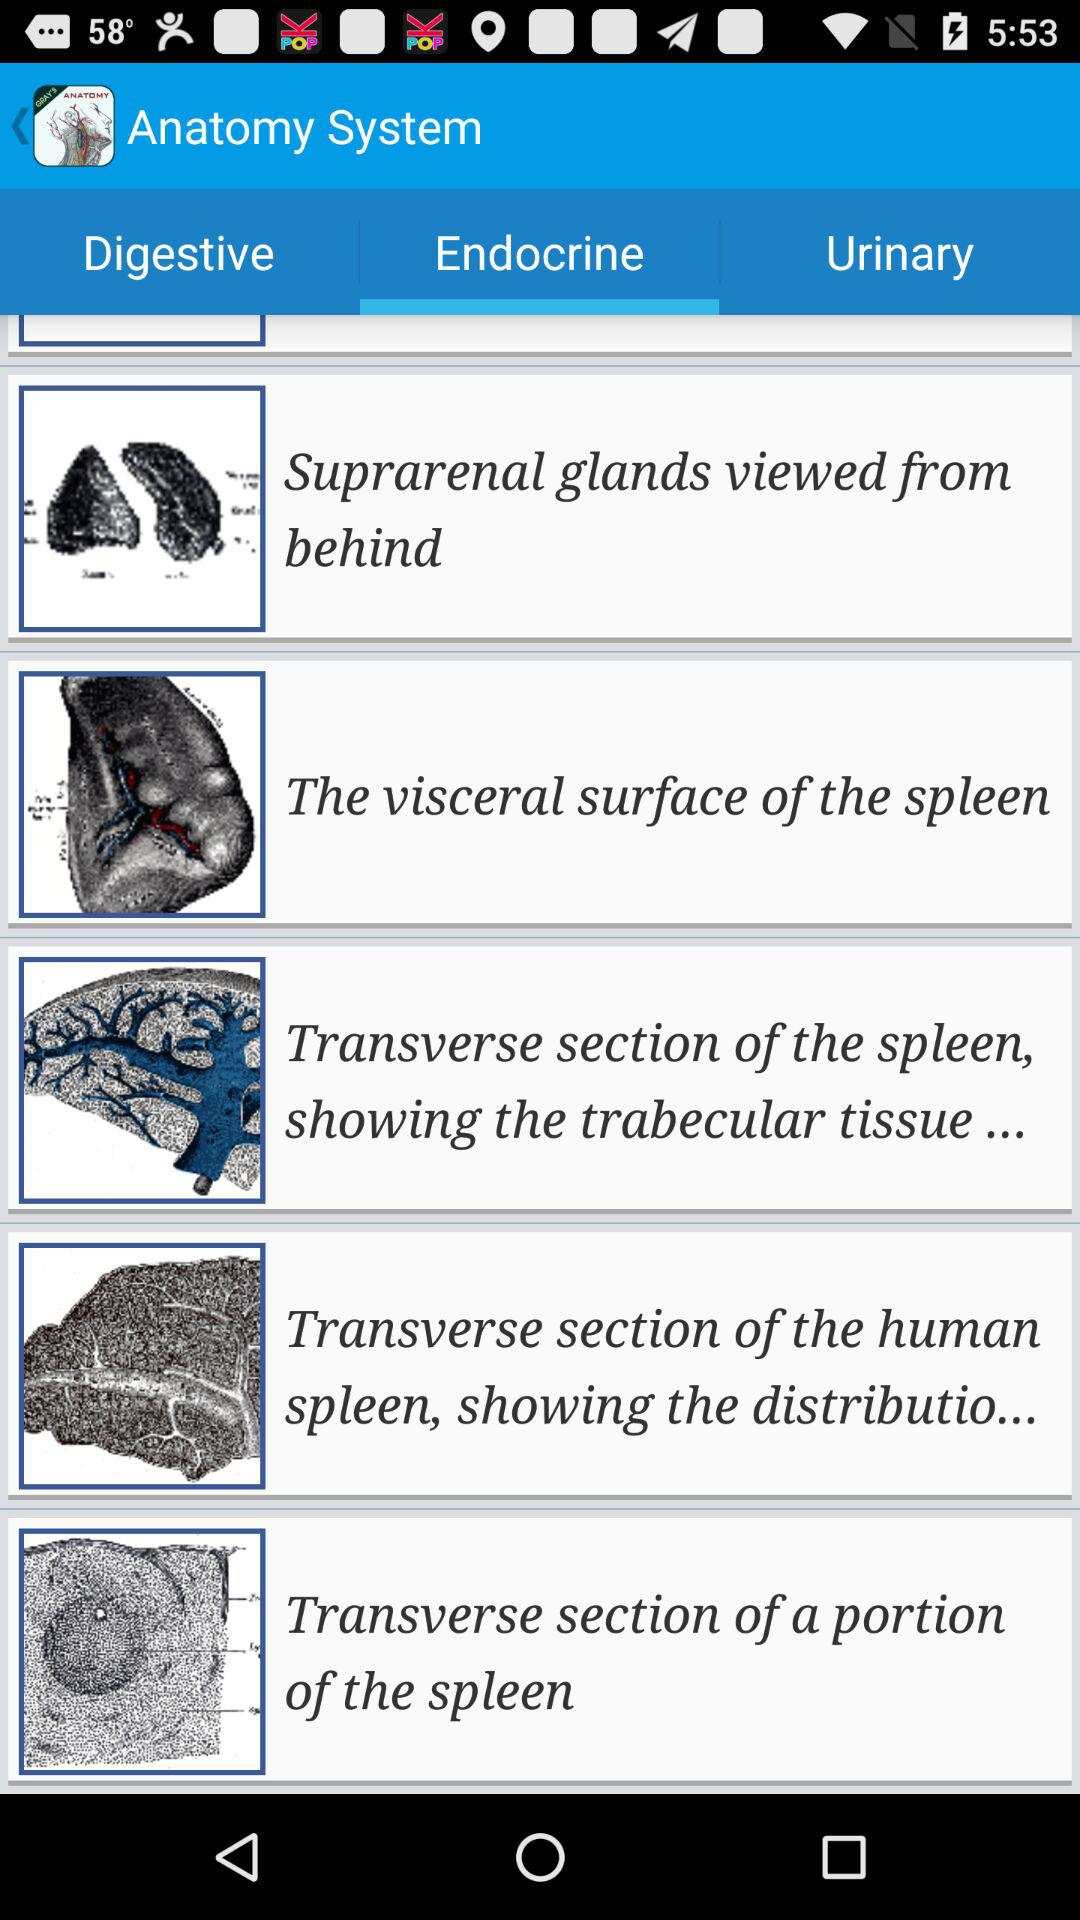What is the name of the application? The name of the application is "Anatomy System". 